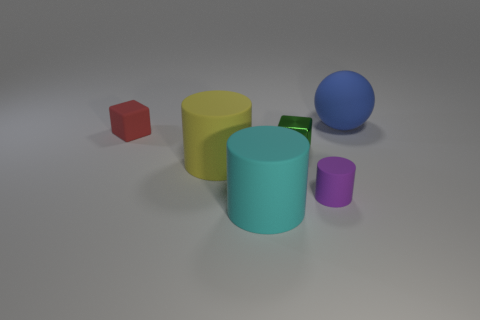Subtract 1 cylinders. How many cylinders are left? 2 Subtract all big cylinders. How many cylinders are left? 1 Add 1 large blue things. How many objects exist? 7 Subtract all spheres. How many objects are left? 5 Subtract all large matte spheres. Subtract all big yellow rubber cylinders. How many objects are left? 4 Add 1 tiny matte blocks. How many tiny matte blocks are left? 2 Add 6 big yellow things. How many big yellow things exist? 7 Subtract 0 gray cylinders. How many objects are left? 6 